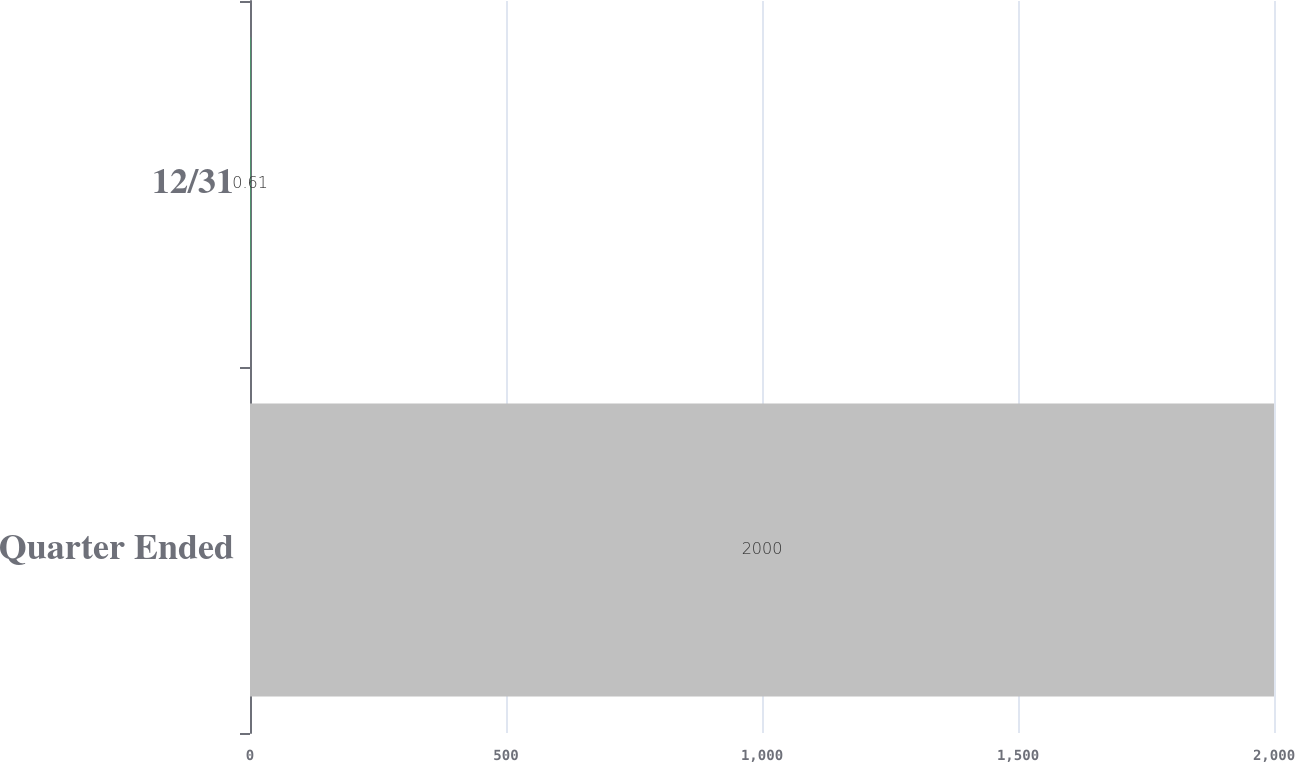Convert chart to OTSL. <chart><loc_0><loc_0><loc_500><loc_500><bar_chart><fcel>Quarter Ended<fcel>12/31<nl><fcel>2000<fcel>0.61<nl></chart> 